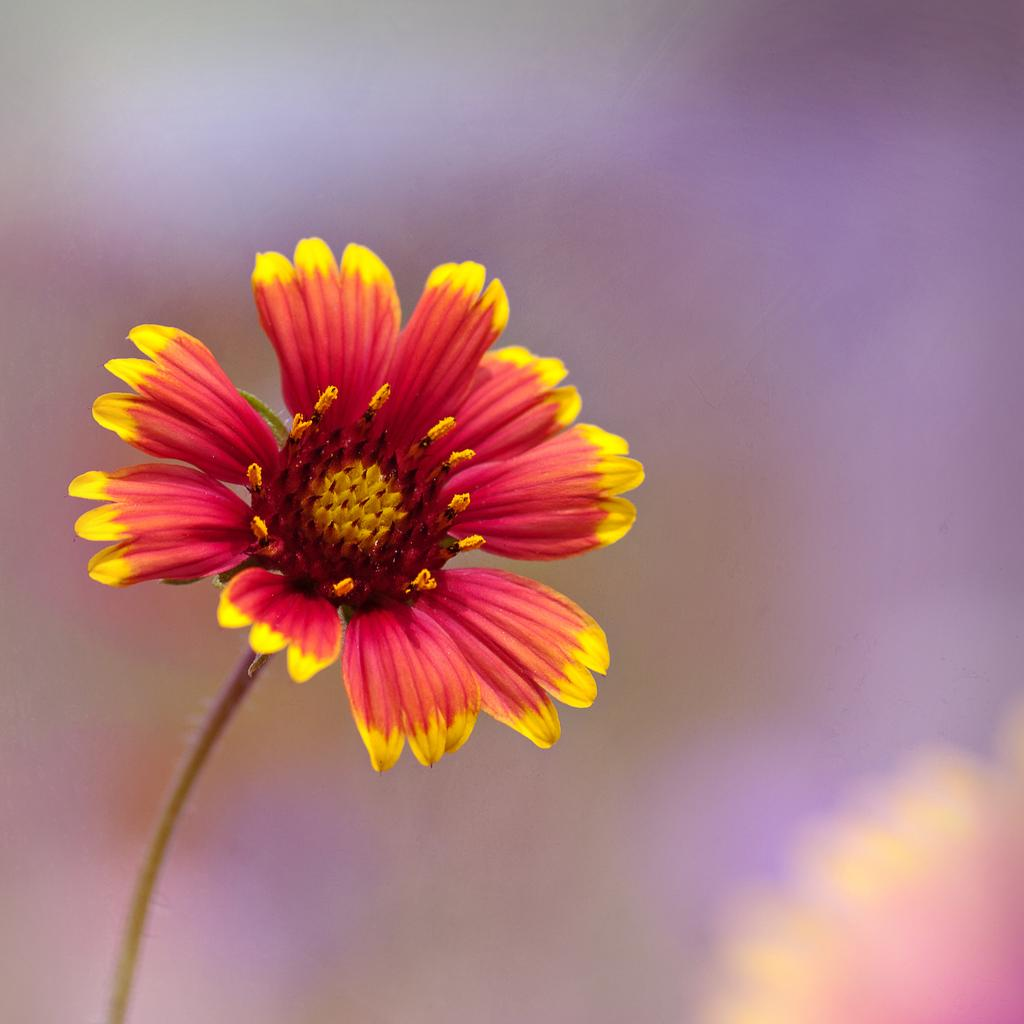What is the main subject of the image? There is a flower in the image. Can you describe the flower's structure? The flower has a stem, and its petals are red with yellow ends. What can be found in the center of the flower? There are pollen grains in the center of the flower. How would you describe the background of the image? The background of the image is blurry. What type of lamp is hanging from the flesh in the image? There is no lamp or flesh present in the image; it features a flower with a blurry background. 